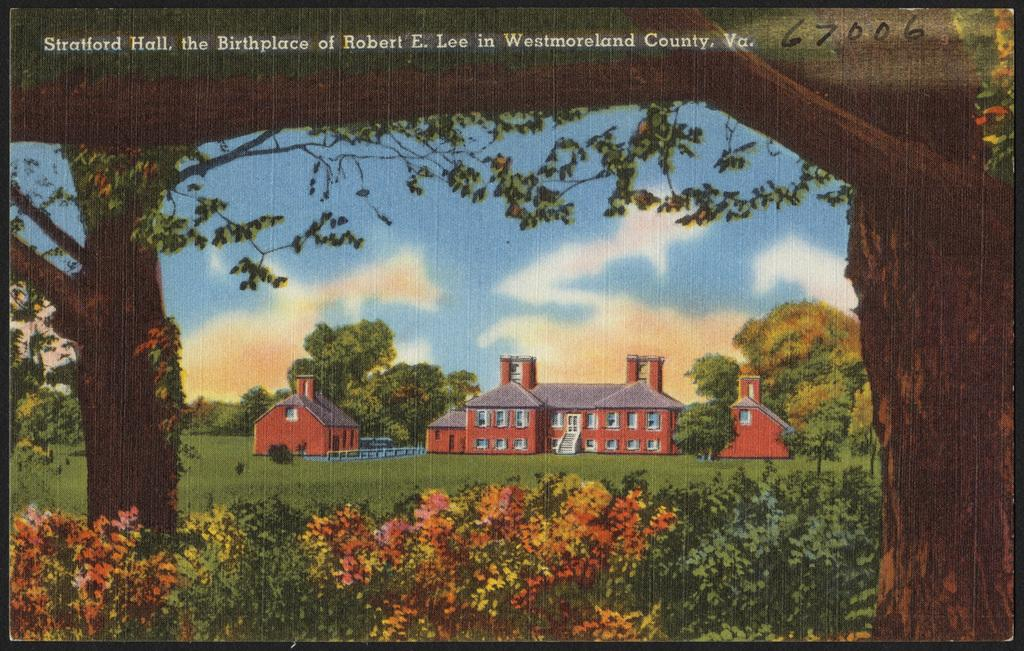What is depicted on the paper in the image? The paper contains drawings of houses. What can be seen in the background of the drawings on the paper? There are trees behind the houses on the paper, and the sky is visible in the background. Is there any text on the paper? Yes, there is writing on the paper. How does the fire blow the houses down in the image? There is no fire or blowing of houses down in the image; it only contains drawings of houses with trees and sky in the background, along with writing on the paper. 